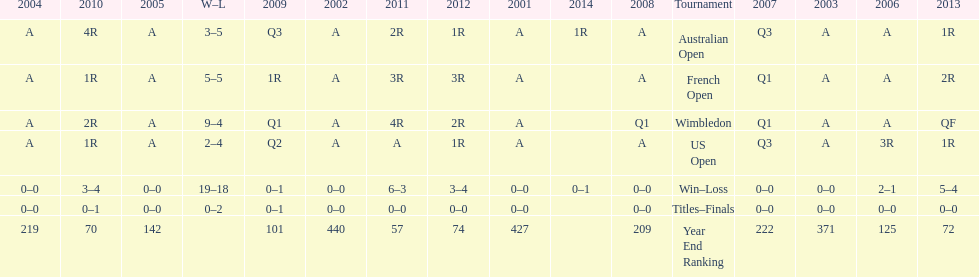Which year end ranking was higher, 2004 or 2011? 2011. 